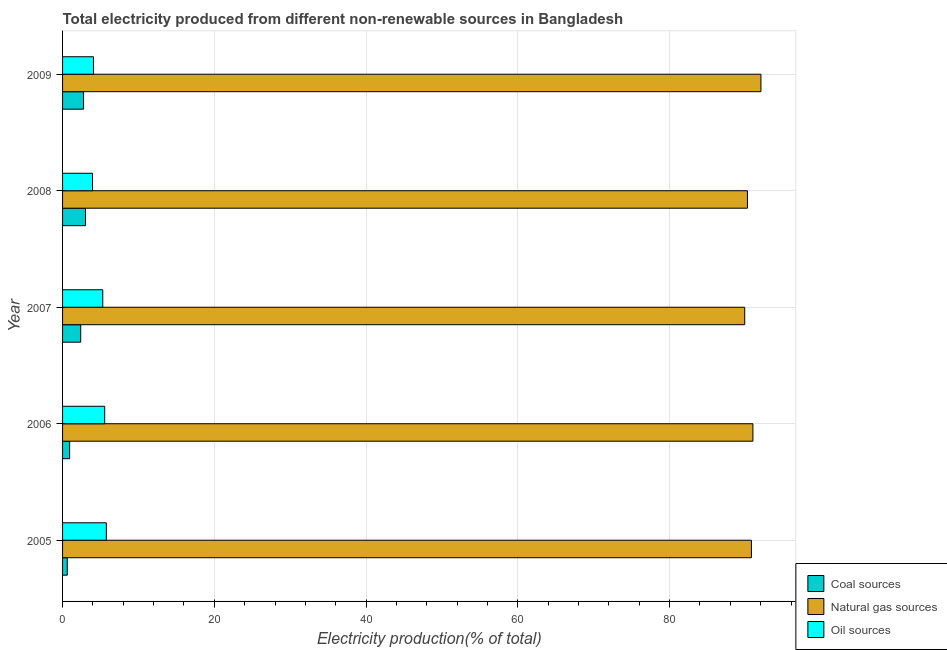How many different coloured bars are there?
Offer a terse response. 3. How many bars are there on the 1st tick from the bottom?
Keep it short and to the point. 3. What is the percentage of electricity produced by coal in 2005?
Provide a succinct answer. 0.62. Across all years, what is the maximum percentage of electricity produced by natural gas?
Keep it short and to the point. 92.03. Across all years, what is the minimum percentage of electricity produced by oil sources?
Your answer should be very brief. 3.95. What is the total percentage of electricity produced by oil sources in the graph?
Provide a succinct answer. 24.64. What is the difference between the percentage of electricity produced by natural gas in 2005 and that in 2009?
Keep it short and to the point. -1.25. What is the difference between the percentage of electricity produced by oil sources in 2007 and the percentage of electricity produced by coal in 2008?
Provide a short and direct response. 2.27. What is the average percentage of electricity produced by oil sources per year?
Provide a short and direct response. 4.93. In the year 2006, what is the difference between the percentage of electricity produced by natural gas and percentage of electricity produced by oil sources?
Make the answer very short. 85.42. What is the ratio of the percentage of electricity produced by coal in 2006 to that in 2009?
Make the answer very short. 0.34. Is the percentage of electricity produced by natural gas in 2007 less than that in 2009?
Provide a succinct answer. Yes. Is the difference between the percentage of electricity produced by oil sources in 2005 and 2006 greater than the difference between the percentage of electricity produced by natural gas in 2005 and 2006?
Give a very brief answer. Yes. What is the difference between the highest and the second highest percentage of electricity produced by oil sources?
Keep it short and to the point. 0.22. What is the difference between the highest and the lowest percentage of electricity produced by oil sources?
Give a very brief answer. 1.82. Is the sum of the percentage of electricity produced by coal in 2007 and 2008 greater than the maximum percentage of electricity produced by oil sources across all years?
Your response must be concise. No. What does the 1st bar from the top in 2007 represents?
Provide a short and direct response. Oil sources. What does the 2nd bar from the bottom in 2009 represents?
Keep it short and to the point. Natural gas sources. Is it the case that in every year, the sum of the percentage of electricity produced by coal and percentage of electricity produced by natural gas is greater than the percentage of electricity produced by oil sources?
Offer a very short reply. Yes. Are all the bars in the graph horizontal?
Ensure brevity in your answer.  Yes. How many years are there in the graph?
Your response must be concise. 5. Does the graph contain any zero values?
Provide a short and direct response. No. Does the graph contain grids?
Give a very brief answer. Yes. How are the legend labels stacked?
Provide a succinct answer. Vertical. What is the title of the graph?
Make the answer very short. Total electricity produced from different non-renewable sources in Bangladesh. What is the label or title of the X-axis?
Provide a short and direct response. Electricity production(% of total). What is the label or title of the Y-axis?
Offer a very short reply. Year. What is the Electricity production(% of total) in Coal sources in 2005?
Offer a very short reply. 0.62. What is the Electricity production(% of total) of Natural gas sources in 2005?
Provide a succinct answer. 90.78. What is the Electricity production(% of total) of Oil sources in 2005?
Ensure brevity in your answer.  5.77. What is the Electricity production(% of total) in Coal sources in 2006?
Make the answer very short. 0.93. What is the Electricity production(% of total) in Natural gas sources in 2006?
Provide a short and direct response. 90.98. What is the Electricity production(% of total) of Oil sources in 2006?
Offer a terse response. 5.55. What is the Electricity production(% of total) of Coal sources in 2007?
Offer a terse response. 2.39. What is the Electricity production(% of total) in Natural gas sources in 2007?
Ensure brevity in your answer.  89.9. What is the Electricity production(% of total) of Oil sources in 2007?
Your answer should be very brief. 5.3. What is the Electricity production(% of total) in Coal sources in 2008?
Your answer should be very brief. 3.02. What is the Electricity production(% of total) of Natural gas sources in 2008?
Ensure brevity in your answer.  90.26. What is the Electricity production(% of total) of Oil sources in 2008?
Your answer should be very brief. 3.95. What is the Electricity production(% of total) in Coal sources in 2009?
Your answer should be very brief. 2.77. What is the Electricity production(% of total) of Natural gas sources in 2009?
Your answer should be compact. 92.03. What is the Electricity production(% of total) of Oil sources in 2009?
Make the answer very short. 4.08. Across all years, what is the maximum Electricity production(% of total) in Coal sources?
Your answer should be compact. 3.02. Across all years, what is the maximum Electricity production(% of total) in Natural gas sources?
Offer a very short reply. 92.03. Across all years, what is the maximum Electricity production(% of total) in Oil sources?
Keep it short and to the point. 5.77. Across all years, what is the minimum Electricity production(% of total) in Coal sources?
Offer a very short reply. 0.62. Across all years, what is the minimum Electricity production(% of total) of Natural gas sources?
Ensure brevity in your answer.  89.9. Across all years, what is the minimum Electricity production(% of total) in Oil sources?
Ensure brevity in your answer.  3.95. What is the total Electricity production(% of total) of Coal sources in the graph?
Your answer should be very brief. 9.73. What is the total Electricity production(% of total) in Natural gas sources in the graph?
Your response must be concise. 453.95. What is the total Electricity production(% of total) of Oil sources in the graph?
Offer a very short reply. 24.64. What is the difference between the Electricity production(% of total) of Coal sources in 2005 and that in 2006?
Give a very brief answer. -0.32. What is the difference between the Electricity production(% of total) of Natural gas sources in 2005 and that in 2006?
Make the answer very short. -0.2. What is the difference between the Electricity production(% of total) in Oil sources in 2005 and that in 2006?
Offer a very short reply. 0.22. What is the difference between the Electricity production(% of total) in Coal sources in 2005 and that in 2007?
Offer a very short reply. -1.77. What is the difference between the Electricity production(% of total) of Natural gas sources in 2005 and that in 2007?
Your response must be concise. 0.88. What is the difference between the Electricity production(% of total) in Oil sources in 2005 and that in 2007?
Your answer should be very brief. 0.47. What is the difference between the Electricity production(% of total) in Coal sources in 2005 and that in 2008?
Your answer should be very brief. -2.41. What is the difference between the Electricity production(% of total) in Natural gas sources in 2005 and that in 2008?
Your answer should be very brief. 0.52. What is the difference between the Electricity production(% of total) in Oil sources in 2005 and that in 2008?
Make the answer very short. 1.82. What is the difference between the Electricity production(% of total) in Coal sources in 2005 and that in 2009?
Your answer should be very brief. -2.15. What is the difference between the Electricity production(% of total) in Natural gas sources in 2005 and that in 2009?
Your answer should be compact. -1.25. What is the difference between the Electricity production(% of total) of Oil sources in 2005 and that in 2009?
Your response must be concise. 1.69. What is the difference between the Electricity production(% of total) of Coal sources in 2006 and that in 2007?
Provide a short and direct response. -1.46. What is the difference between the Electricity production(% of total) in Oil sources in 2006 and that in 2007?
Make the answer very short. 0.25. What is the difference between the Electricity production(% of total) in Coal sources in 2006 and that in 2008?
Ensure brevity in your answer.  -2.09. What is the difference between the Electricity production(% of total) in Natural gas sources in 2006 and that in 2008?
Your answer should be very brief. 0.72. What is the difference between the Electricity production(% of total) of Oil sources in 2006 and that in 2008?
Your answer should be very brief. 1.6. What is the difference between the Electricity production(% of total) in Coal sources in 2006 and that in 2009?
Your answer should be very brief. -1.84. What is the difference between the Electricity production(% of total) in Natural gas sources in 2006 and that in 2009?
Keep it short and to the point. -1.06. What is the difference between the Electricity production(% of total) of Oil sources in 2006 and that in 2009?
Your answer should be compact. 1.48. What is the difference between the Electricity production(% of total) in Coal sources in 2007 and that in 2008?
Your answer should be very brief. -0.64. What is the difference between the Electricity production(% of total) of Natural gas sources in 2007 and that in 2008?
Provide a short and direct response. -0.36. What is the difference between the Electricity production(% of total) in Oil sources in 2007 and that in 2008?
Provide a succinct answer. 1.35. What is the difference between the Electricity production(% of total) in Coal sources in 2007 and that in 2009?
Ensure brevity in your answer.  -0.38. What is the difference between the Electricity production(% of total) of Natural gas sources in 2007 and that in 2009?
Make the answer very short. -2.14. What is the difference between the Electricity production(% of total) of Oil sources in 2007 and that in 2009?
Provide a short and direct response. 1.22. What is the difference between the Electricity production(% of total) in Coal sources in 2008 and that in 2009?
Keep it short and to the point. 0.25. What is the difference between the Electricity production(% of total) of Natural gas sources in 2008 and that in 2009?
Give a very brief answer. -1.78. What is the difference between the Electricity production(% of total) in Oil sources in 2008 and that in 2009?
Ensure brevity in your answer.  -0.13. What is the difference between the Electricity production(% of total) of Coal sources in 2005 and the Electricity production(% of total) of Natural gas sources in 2006?
Give a very brief answer. -90.36. What is the difference between the Electricity production(% of total) of Coal sources in 2005 and the Electricity production(% of total) of Oil sources in 2006?
Give a very brief answer. -4.94. What is the difference between the Electricity production(% of total) in Natural gas sources in 2005 and the Electricity production(% of total) in Oil sources in 2006?
Provide a succinct answer. 85.23. What is the difference between the Electricity production(% of total) in Coal sources in 2005 and the Electricity production(% of total) in Natural gas sources in 2007?
Your answer should be very brief. -89.28. What is the difference between the Electricity production(% of total) of Coal sources in 2005 and the Electricity production(% of total) of Oil sources in 2007?
Make the answer very short. -4.68. What is the difference between the Electricity production(% of total) in Natural gas sources in 2005 and the Electricity production(% of total) in Oil sources in 2007?
Give a very brief answer. 85.48. What is the difference between the Electricity production(% of total) of Coal sources in 2005 and the Electricity production(% of total) of Natural gas sources in 2008?
Ensure brevity in your answer.  -89.64. What is the difference between the Electricity production(% of total) in Coal sources in 2005 and the Electricity production(% of total) in Oil sources in 2008?
Offer a very short reply. -3.33. What is the difference between the Electricity production(% of total) in Natural gas sources in 2005 and the Electricity production(% of total) in Oil sources in 2008?
Your response must be concise. 86.83. What is the difference between the Electricity production(% of total) of Coal sources in 2005 and the Electricity production(% of total) of Natural gas sources in 2009?
Your answer should be very brief. -91.42. What is the difference between the Electricity production(% of total) of Coal sources in 2005 and the Electricity production(% of total) of Oil sources in 2009?
Ensure brevity in your answer.  -3.46. What is the difference between the Electricity production(% of total) of Natural gas sources in 2005 and the Electricity production(% of total) of Oil sources in 2009?
Provide a succinct answer. 86.71. What is the difference between the Electricity production(% of total) of Coal sources in 2006 and the Electricity production(% of total) of Natural gas sources in 2007?
Make the answer very short. -88.96. What is the difference between the Electricity production(% of total) of Coal sources in 2006 and the Electricity production(% of total) of Oil sources in 2007?
Keep it short and to the point. -4.36. What is the difference between the Electricity production(% of total) in Natural gas sources in 2006 and the Electricity production(% of total) in Oil sources in 2007?
Offer a terse response. 85.68. What is the difference between the Electricity production(% of total) of Coal sources in 2006 and the Electricity production(% of total) of Natural gas sources in 2008?
Your answer should be compact. -89.32. What is the difference between the Electricity production(% of total) in Coal sources in 2006 and the Electricity production(% of total) in Oil sources in 2008?
Offer a terse response. -3.01. What is the difference between the Electricity production(% of total) in Natural gas sources in 2006 and the Electricity production(% of total) in Oil sources in 2008?
Your answer should be very brief. 87.03. What is the difference between the Electricity production(% of total) of Coal sources in 2006 and the Electricity production(% of total) of Natural gas sources in 2009?
Provide a short and direct response. -91.1. What is the difference between the Electricity production(% of total) in Coal sources in 2006 and the Electricity production(% of total) in Oil sources in 2009?
Keep it short and to the point. -3.14. What is the difference between the Electricity production(% of total) of Natural gas sources in 2006 and the Electricity production(% of total) of Oil sources in 2009?
Keep it short and to the point. 86.9. What is the difference between the Electricity production(% of total) in Coal sources in 2007 and the Electricity production(% of total) in Natural gas sources in 2008?
Your answer should be compact. -87.87. What is the difference between the Electricity production(% of total) of Coal sources in 2007 and the Electricity production(% of total) of Oil sources in 2008?
Ensure brevity in your answer.  -1.56. What is the difference between the Electricity production(% of total) of Natural gas sources in 2007 and the Electricity production(% of total) of Oil sources in 2008?
Offer a terse response. 85.95. What is the difference between the Electricity production(% of total) in Coal sources in 2007 and the Electricity production(% of total) in Natural gas sources in 2009?
Provide a succinct answer. -89.65. What is the difference between the Electricity production(% of total) in Coal sources in 2007 and the Electricity production(% of total) in Oil sources in 2009?
Offer a very short reply. -1.69. What is the difference between the Electricity production(% of total) of Natural gas sources in 2007 and the Electricity production(% of total) of Oil sources in 2009?
Keep it short and to the point. 85.82. What is the difference between the Electricity production(% of total) of Coal sources in 2008 and the Electricity production(% of total) of Natural gas sources in 2009?
Give a very brief answer. -89.01. What is the difference between the Electricity production(% of total) in Coal sources in 2008 and the Electricity production(% of total) in Oil sources in 2009?
Offer a terse response. -1.05. What is the difference between the Electricity production(% of total) of Natural gas sources in 2008 and the Electricity production(% of total) of Oil sources in 2009?
Your answer should be compact. 86.18. What is the average Electricity production(% of total) of Coal sources per year?
Offer a very short reply. 1.95. What is the average Electricity production(% of total) of Natural gas sources per year?
Give a very brief answer. 90.79. What is the average Electricity production(% of total) of Oil sources per year?
Your answer should be compact. 4.93. In the year 2005, what is the difference between the Electricity production(% of total) of Coal sources and Electricity production(% of total) of Natural gas sources?
Offer a terse response. -90.17. In the year 2005, what is the difference between the Electricity production(% of total) of Coal sources and Electricity production(% of total) of Oil sources?
Provide a short and direct response. -5.15. In the year 2005, what is the difference between the Electricity production(% of total) in Natural gas sources and Electricity production(% of total) in Oil sources?
Provide a succinct answer. 85.01. In the year 2006, what is the difference between the Electricity production(% of total) of Coal sources and Electricity production(% of total) of Natural gas sources?
Your answer should be compact. -90.04. In the year 2006, what is the difference between the Electricity production(% of total) of Coal sources and Electricity production(% of total) of Oil sources?
Ensure brevity in your answer.  -4.62. In the year 2006, what is the difference between the Electricity production(% of total) of Natural gas sources and Electricity production(% of total) of Oil sources?
Provide a succinct answer. 85.42. In the year 2007, what is the difference between the Electricity production(% of total) in Coal sources and Electricity production(% of total) in Natural gas sources?
Give a very brief answer. -87.51. In the year 2007, what is the difference between the Electricity production(% of total) in Coal sources and Electricity production(% of total) in Oil sources?
Your answer should be very brief. -2.91. In the year 2007, what is the difference between the Electricity production(% of total) of Natural gas sources and Electricity production(% of total) of Oil sources?
Provide a succinct answer. 84.6. In the year 2008, what is the difference between the Electricity production(% of total) in Coal sources and Electricity production(% of total) in Natural gas sources?
Make the answer very short. -87.23. In the year 2008, what is the difference between the Electricity production(% of total) in Coal sources and Electricity production(% of total) in Oil sources?
Your response must be concise. -0.92. In the year 2008, what is the difference between the Electricity production(% of total) of Natural gas sources and Electricity production(% of total) of Oil sources?
Your answer should be compact. 86.31. In the year 2009, what is the difference between the Electricity production(% of total) in Coal sources and Electricity production(% of total) in Natural gas sources?
Your answer should be compact. -89.27. In the year 2009, what is the difference between the Electricity production(% of total) in Coal sources and Electricity production(% of total) in Oil sources?
Your response must be concise. -1.31. In the year 2009, what is the difference between the Electricity production(% of total) in Natural gas sources and Electricity production(% of total) in Oil sources?
Ensure brevity in your answer.  87.96. What is the ratio of the Electricity production(% of total) in Coal sources in 2005 to that in 2006?
Keep it short and to the point. 0.66. What is the ratio of the Electricity production(% of total) in Oil sources in 2005 to that in 2006?
Give a very brief answer. 1.04. What is the ratio of the Electricity production(% of total) of Coal sources in 2005 to that in 2007?
Offer a very short reply. 0.26. What is the ratio of the Electricity production(% of total) in Natural gas sources in 2005 to that in 2007?
Offer a very short reply. 1.01. What is the ratio of the Electricity production(% of total) in Oil sources in 2005 to that in 2007?
Offer a very short reply. 1.09. What is the ratio of the Electricity production(% of total) of Coal sources in 2005 to that in 2008?
Make the answer very short. 0.2. What is the ratio of the Electricity production(% of total) in Natural gas sources in 2005 to that in 2008?
Provide a succinct answer. 1.01. What is the ratio of the Electricity production(% of total) of Oil sources in 2005 to that in 2008?
Ensure brevity in your answer.  1.46. What is the ratio of the Electricity production(% of total) in Coal sources in 2005 to that in 2009?
Offer a terse response. 0.22. What is the ratio of the Electricity production(% of total) of Natural gas sources in 2005 to that in 2009?
Make the answer very short. 0.99. What is the ratio of the Electricity production(% of total) of Oil sources in 2005 to that in 2009?
Offer a very short reply. 1.42. What is the ratio of the Electricity production(% of total) in Coal sources in 2006 to that in 2007?
Ensure brevity in your answer.  0.39. What is the ratio of the Electricity production(% of total) of Natural gas sources in 2006 to that in 2007?
Your answer should be compact. 1.01. What is the ratio of the Electricity production(% of total) in Oil sources in 2006 to that in 2007?
Ensure brevity in your answer.  1.05. What is the ratio of the Electricity production(% of total) of Coal sources in 2006 to that in 2008?
Your answer should be compact. 0.31. What is the ratio of the Electricity production(% of total) in Natural gas sources in 2006 to that in 2008?
Offer a very short reply. 1.01. What is the ratio of the Electricity production(% of total) in Oil sources in 2006 to that in 2008?
Offer a very short reply. 1.41. What is the ratio of the Electricity production(% of total) in Coal sources in 2006 to that in 2009?
Offer a very short reply. 0.34. What is the ratio of the Electricity production(% of total) of Oil sources in 2006 to that in 2009?
Give a very brief answer. 1.36. What is the ratio of the Electricity production(% of total) in Coal sources in 2007 to that in 2008?
Offer a very short reply. 0.79. What is the ratio of the Electricity production(% of total) in Natural gas sources in 2007 to that in 2008?
Provide a short and direct response. 1. What is the ratio of the Electricity production(% of total) of Oil sources in 2007 to that in 2008?
Your answer should be compact. 1.34. What is the ratio of the Electricity production(% of total) in Coal sources in 2007 to that in 2009?
Offer a very short reply. 0.86. What is the ratio of the Electricity production(% of total) in Natural gas sources in 2007 to that in 2009?
Make the answer very short. 0.98. What is the ratio of the Electricity production(% of total) in Oil sources in 2007 to that in 2009?
Your answer should be very brief. 1.3. What is the ratio of the Electricity production(% of total) in Coal sources in 2008 to that in 2009?
Offer a very short reply. 1.09. What is the ratio of the Electricity production(% of total) of Natural gas sources in 2008 to that in 2009?
Give a very brief answer. 0.98. What is the ratio of the Electricity production(% of total) in Oil sources in 2008 to that in 2009?
Provide a short and direct response. 0.97. What is the difference between the highest and the second highest Electricity production(% of total) in Coal sources?
Ensure brevity in your answer.  0.25. What is the difference between the highest and the second highest Electricity production(% of total) in Natural gas sources?
Provide a short and direct response. 1.06. What is the difference between the highest and the second highest Electricity production(% of total) of Oil sources?
Your answer should be very brief. 0.22. What is the difference between the highest and the lowest Electricity production(% of total) in Coal sources?
Provide a short and direct response. 2.41. What is the difference between the highest and the lowest Electricity production(% of total) of Natural gas sources?
Provide a short and direct response. 2.14. What is the difference between the highest and the lowest Electricity production(% of total) in Oil sources?
Provide a short and direct response. 1.82. 